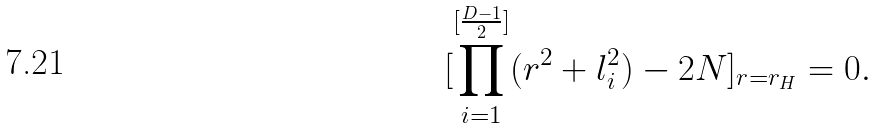Convert formula to latex. <formula><loc_0><loc_0><loc_500><loc_500>[ \prod _ { i = 1 } ^ { [ \frac { D - 1 } { 2 } ] } ( r ^ { 2 } + l _ { i } ^ { 2 } ) - 2 N ] _ { r = r _ { H } } = 0 .</formula> 